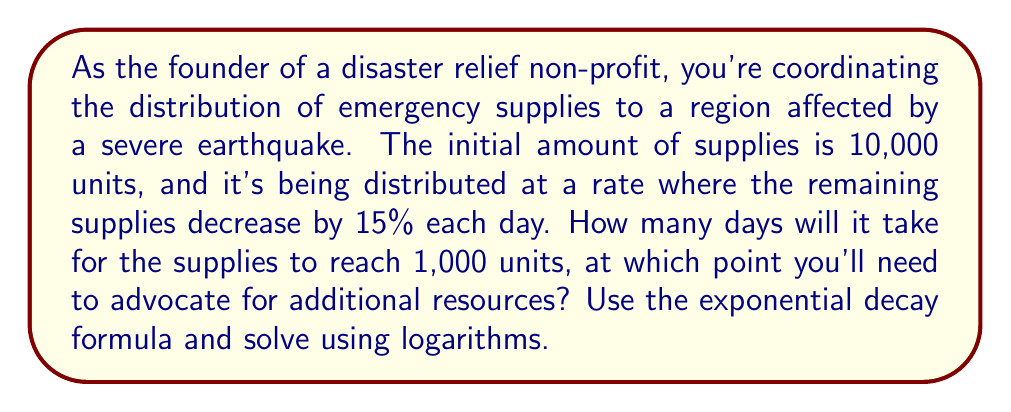What is the answer to this math problem? Let's approach this step-by-step using the exponential decay formula and logarithms:

1) The exponential decay formula is:
   $A(t) = A_0 \cdot (1-r)^t$

   Where:
   $A(t)$ is the amount at time $t$
   $A_0$ is the initial amount
   $r$ is the decay rate
   $t$ is the time

2) We know:
   $A_0 = 10,000$ (initial amount)
   $r = 0.15$ (15% decay rate)
   $A(t) = 1,000$ (final amount we're solving for)

3) Let's plug these into our formula:
   $1,000 = 10,000 \cdot (1-0.15)^t$

4) Simplify:
   $1,000 = 10,000 \cdot (0.85)^t$

5) Divide both sides by 10,000:
   $0.1 = (0.85)^t$

6) Now we can use logarithms. Take the natural log of both sides:
   $\ln(0.1) = \ln((0.85)^t)$

7) Use the logarithm property $\ln(a^b) = b\ln(a)$:
   $\ln(0.1) = t \cdot \ln(0.85)$

8) Solve for $t$:
   $t = \frac{\ln(0.1)}{\ln(0.85)}$

9) Calculate:
   $t \approx 14.96$

10) Since we can't have a fractional day in this context, we round up to the next whole day.
Answer: It will take 15 days for the supplies to reach 1,000 units. 